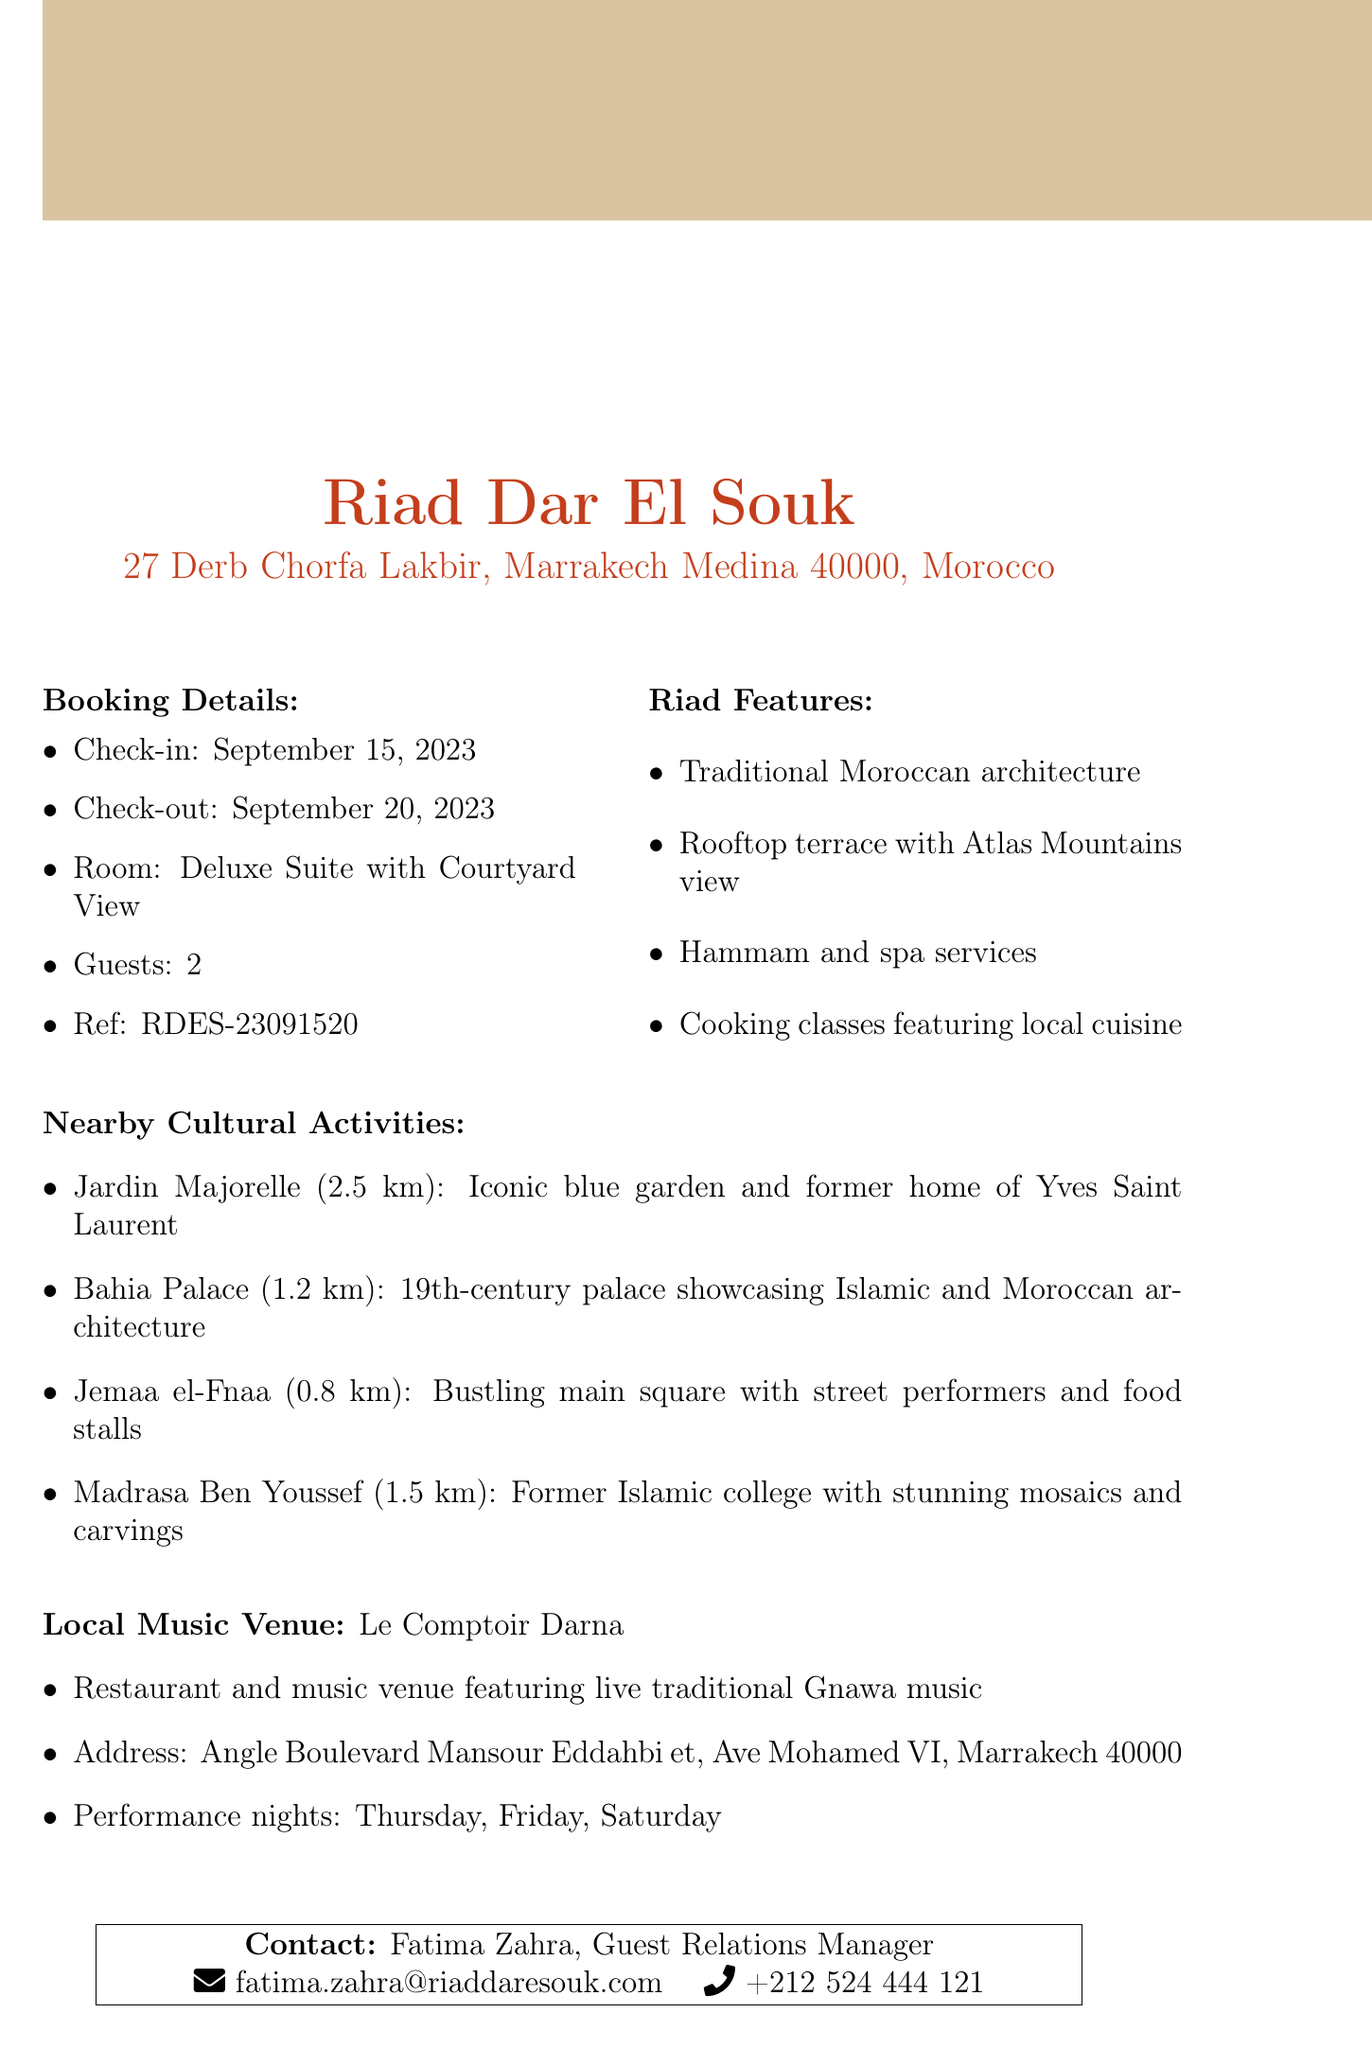What is the name of the riad? The name of the riad is indicated in the document as Riad Dar El Souk.
Answer: Riad Dar El Souk What is the check-out date? The check-out date is specified in the booking details as September 20, 2023.
Answer: September 20, 2023 How many guests can stay in the room? The document mentions that the room is for 2 guests, as stated in the booking details.
Answer: 2 What is one feature of the riad? One feature of the riad includes traditional Moroccan architecture, as listed under riad features.
Answer: Traditional Moroccan architecture Which cultural activity is closest to the riad? The cultural activity located 0.8 km from the riad is specified as Jemaa el-Fnaa, making it the closest.
Answer: Jemaa el-Fnaa What type of music is performed at Le Comptoir Darna? The document specifies that live traditional Gnawa music is performed at Le Comptoir Darna.
Answer: Gnawa Who is the contact person for the riad? The contact person is identified in the document as Fatima Zahra, the Guest Relations Manager.
Answer: Fatima Zahra What is the distance to Bahia Palace? The distance to Bahia Palace is listed as 1.2 km in the nearby cultural activities section.
Answer: 1.2 km On which nights does Le Comptoir Darna have performances? The performance nights at Le Comptoir Darna are Thursday, Friday, and Saturday, as mentioned in the document.
Answer: Thursday, Friday, Saturday 